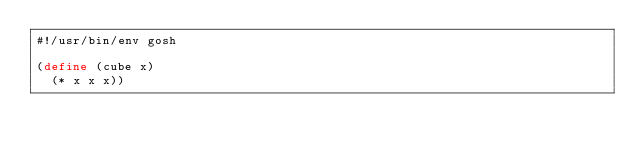Convert code to text. <code><loc_0><loc_0><loc_500><loc_500><_Scheme_>#!/usr/bin/env gosh

(define (cube x)
  (* x x x))
</code> 